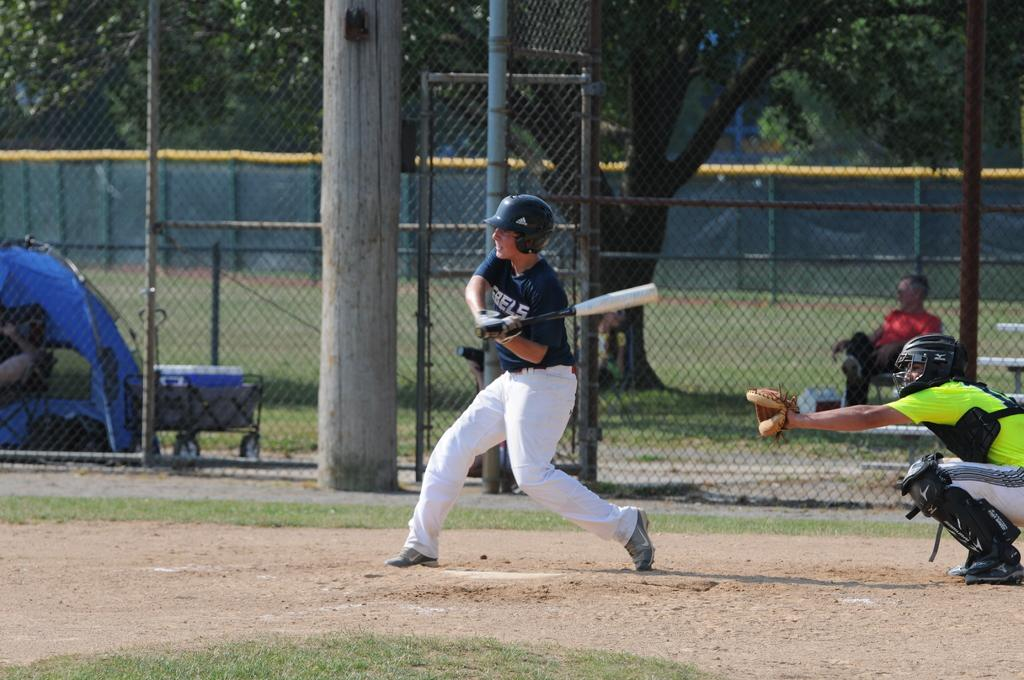What sport are the players engaged in within the image? The players are playing baseball in the image. Where is the baseball game taking place? The baseball game is taking place on a ground. What can be seen in the background of the image? In the background of the image, there are poles, fencing, a man sitting on a chair, and trees. What type of soup is being served to the players during the game? There is no soup present in the image, as it features a baseball game taking place on a ground. Can you see any frogs hopping around on the baseball field? There are no frogs visible in the image; it shows a baseball game with players, a ground, and various background elements. 